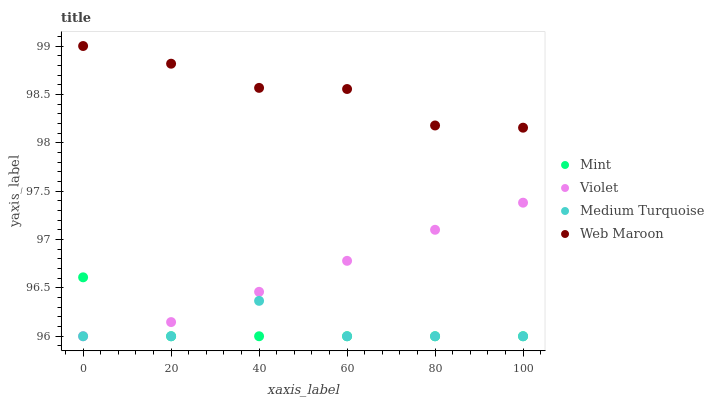Does Mint have the minimum area under the curve?
Answer yes or no. Yes. Does Web Maroon have the maximum area under the curve?
Answer yes or no. Yes. Does Medium Turquoise have the minimum area under the curve?
Answer yes or no. No. Does Medium Turquoise have the maximum area under the curve?
Answer yes or no. No. Is Violet the smoothest?
Answer yes or no. Yes. Is Medium Turquoise the roughest?
Answer yes or no. Yes. Is Mint the smoothest?
Answer yes or no. No. Is Mint the roughest?
Answer yes or no. No. Does Mint have the lowest value?
Answer yes or no. Yes. Does Web Maroon have the highest value?
Answer yes or no. Yes. Does Mint have the highest value?
Answer yes or no. No. Is Violet less than Web Maroon?
Answer yes or no. Yes. Is Web Maroon greater than Medium Turquoise?
Answer yes or no. Yes. Does Medium Turquoise intersect Mint?
Answer yes or no. Yes. Is Medium Turquoise less than Mint?
Answer yes or no. No. Is Medium Turquoise greater than Mint?
Answer yes or no. No. Does Violet intersect Web Maroon?
Answer yes or no. No. 